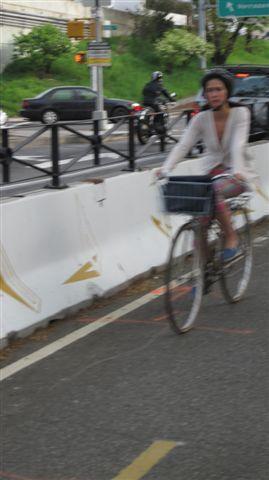How is the women moving?
Select the accurate answer and provide explanation: 'Answer: answer
Rationale: rationale.'
Options: Bicycling, dancing, running, walking. Answer: bicycling.
Rationale: The woman is moving down the street on a bicycle. 